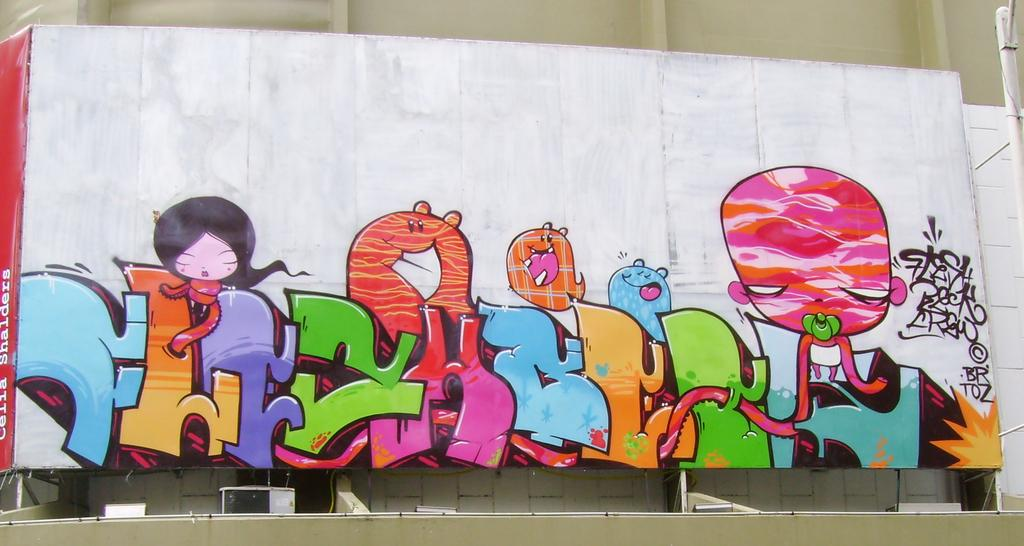What is hanging on the wall in the image? There is a painting on the wall in the image. Where is the painting located in relation to the rest of the image? The painting is in the center of the image. What type of grass can be seen growing on the painting in the image? There is no grass visible on the painting in the image. 